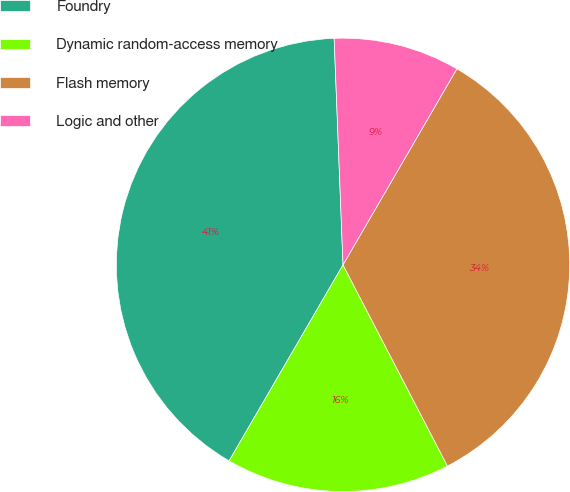<chart> <loc_0><loc_0><loc_500><loc_500><pie_chart><fcel>Foundry<fcel>Dynamic random-access memory<fcel>Flash memory<fcel>Logic and other<nl><fcel>41.0%<fcel>16.0%<fcel>34.0%<fcel>9.0%<nl></chart> 